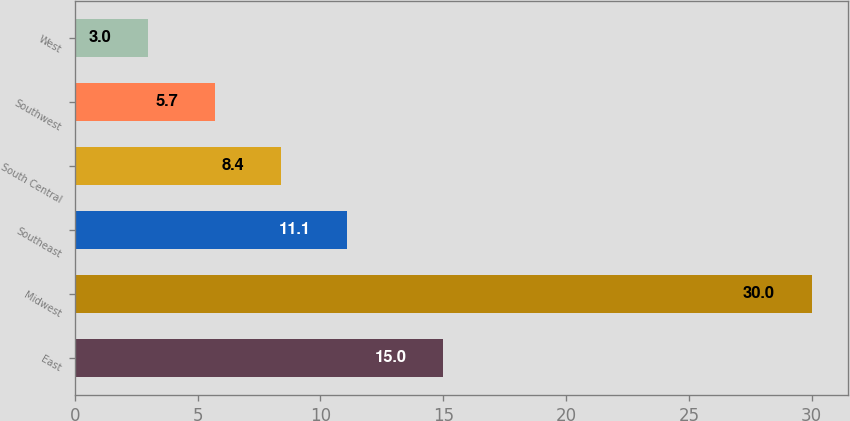Convert chart. <chart><loc_0><loc_0><loc_500><loc_500><bar_chart><fcel>East<fcel>Midwest<fcel>Southeast<fcel>South Central<fcel>Southwest<fcel>West<nl><fcel>15<fcel>30<fcel>11.1<fcel>8.4<fcel>5.7<fcel>3<nl></chart> 